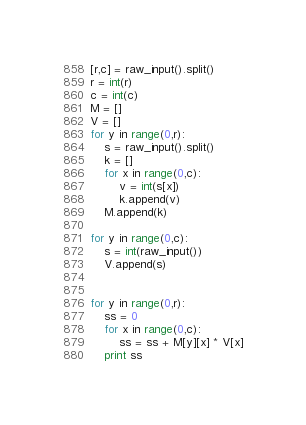<code> <loc_0><loc_0><loc_500><loc_500><_Python_>[r,c] = raw_input().split()
r = int(r)
c = int(c)
M = []
V = []
for y in range(0,r):
    s = raw_input().split()
    k = []
    for x in range(0,c):
        v = int(s[x])
        k.append(v)
    M.append(k)
    
for y in range(0,c):
    s = int(raw_input())
    V.append(s)
    

for y in range(0,r):
    ss = 0
    for x in range(0,c):
        ss = ss + M[y][x] * V[x]
    print ss</code> 